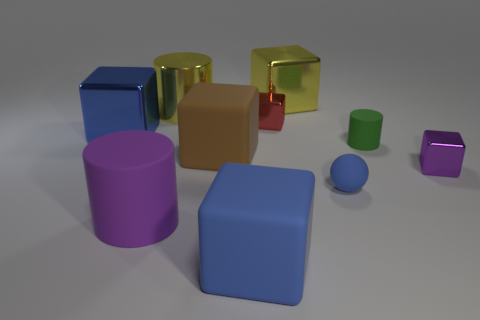Subtract all brown cubes. How many cubes are left? 5 Subtract all matte blocks. How many blocks are left? 4 Subtract all green blocks. Subtract all green cylinders. How many blocks are left? 6 Subtract all blocks. How many objects are left? 4 Subtract all small metal objects. Subtract all tiny shiny objects. How many objects are left? 6 Add 6 big cylinders. How many big cylinders are left? 8 Add 6 tiny green cylinders. How many tiny green cylinders exist? 7 Subtract 1 yellow cylinders. How many objects are left? 9 